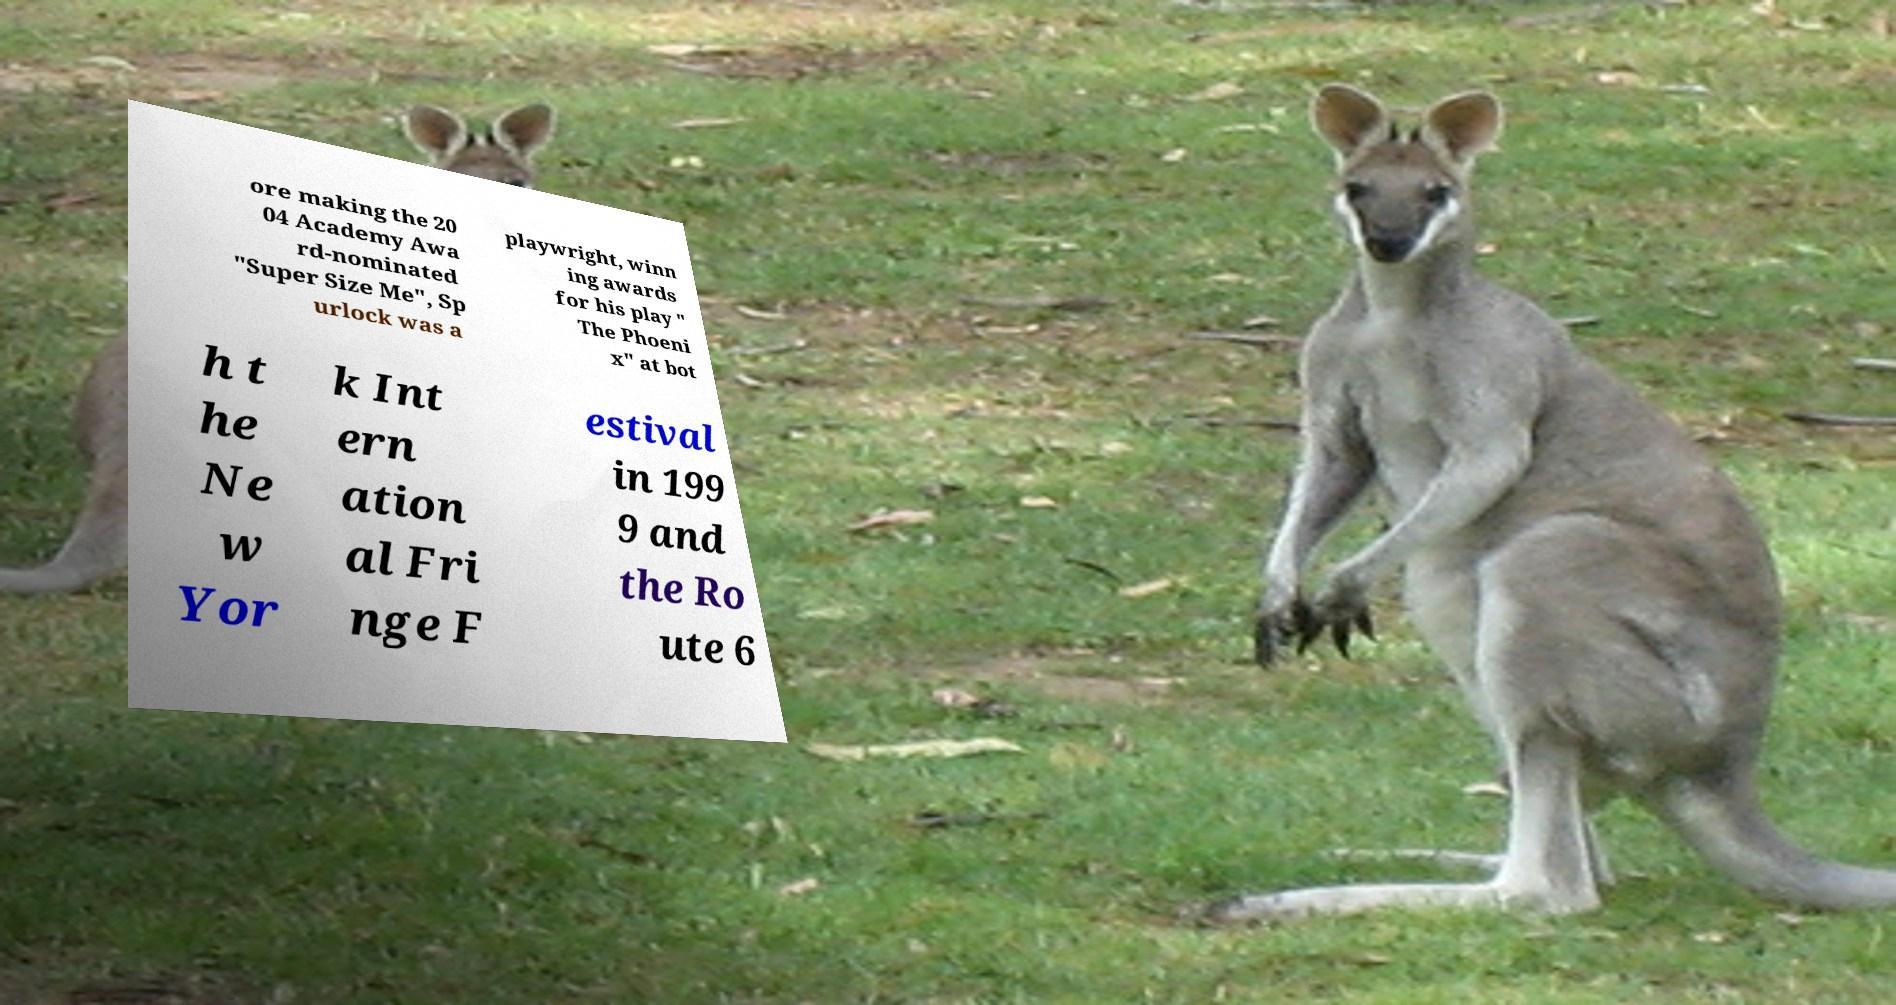Could you extract and type out the text from this image? ore making the 20 04 Academy Awa rd-nominated "Super Size Me", Sp urlock was a playwright, winn ing awards for his play " The Phoeni x" at bot h t he Ne w Yor k Int ern ation al Fri nge F estival in 199 9 and the Ro ute 6 